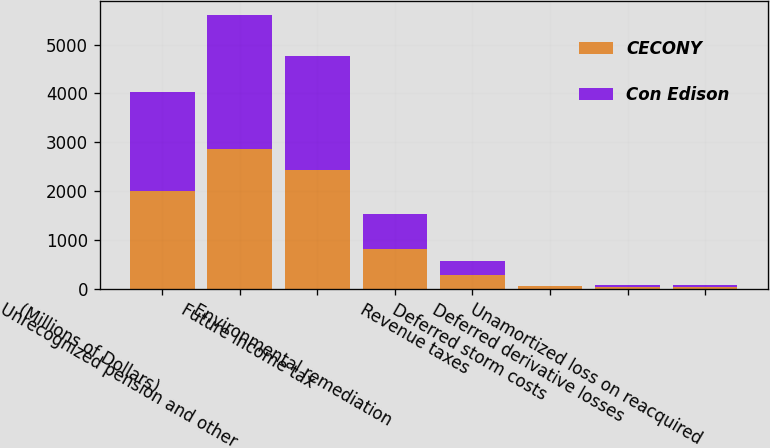<chart> <loc_0><loc_0><loc_500><loc_500><stacked_bar_chart><ecel><fcel>(Millions of Dollars)<fcel>Unrecognized pension and other<fcel>Future income tax<fcel>Environmental remediation<fcel>Revenue taxes<fcel>Deferred storm costs<fcel>Deferred derivative losses<fcel>Unamortized loss on reacquired<nl><fcel>CECONY<fcel>2016<fcel>2874<fcel>2439<fcel>823<fcel>295<fcel>56<fcel>48<fcel>43<nl><fcel>Con Edison<fcel>2016<fcel>2730<fcel>2325<fcel>711<fcel>280<fcel>3<fcel>42<fcel>41<nl></chart> 